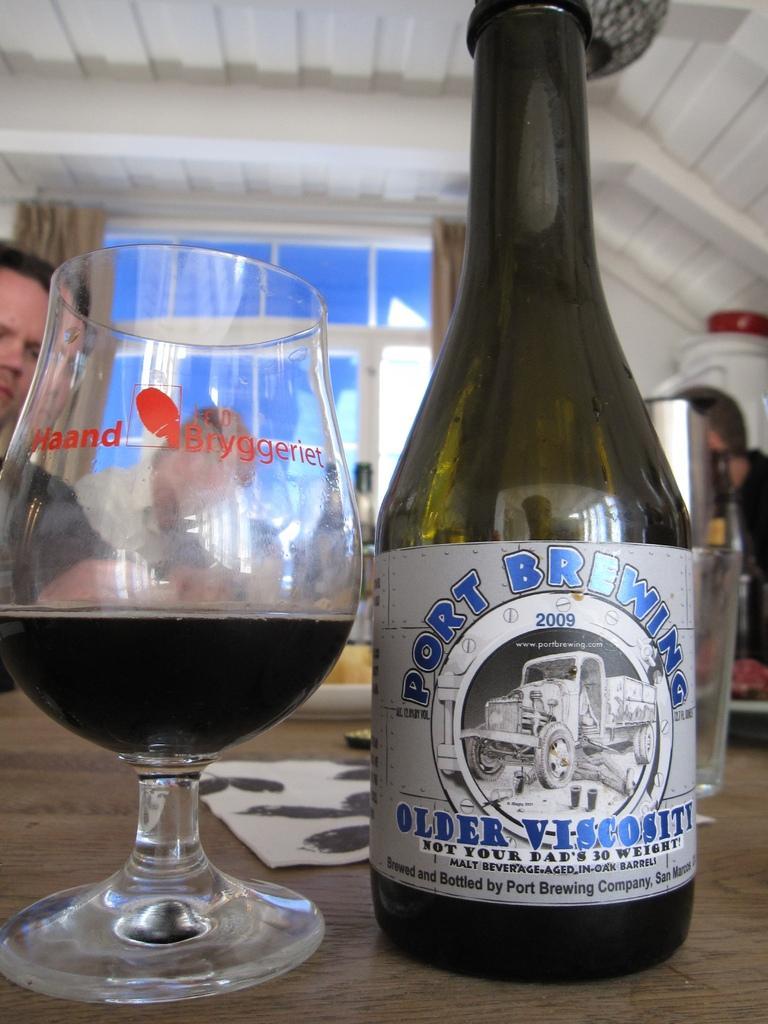Could you give a brief overview of what you see in this image? There is a wine bottle in the right corner and there is a glass of wine beside it and there are few people in the background. 